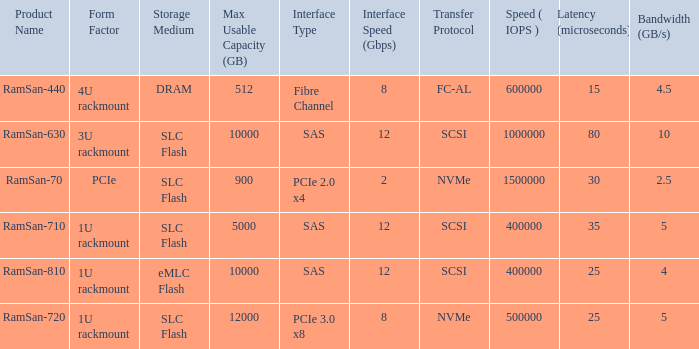List the range distroration for the ramsan-630 3U rackmount. 